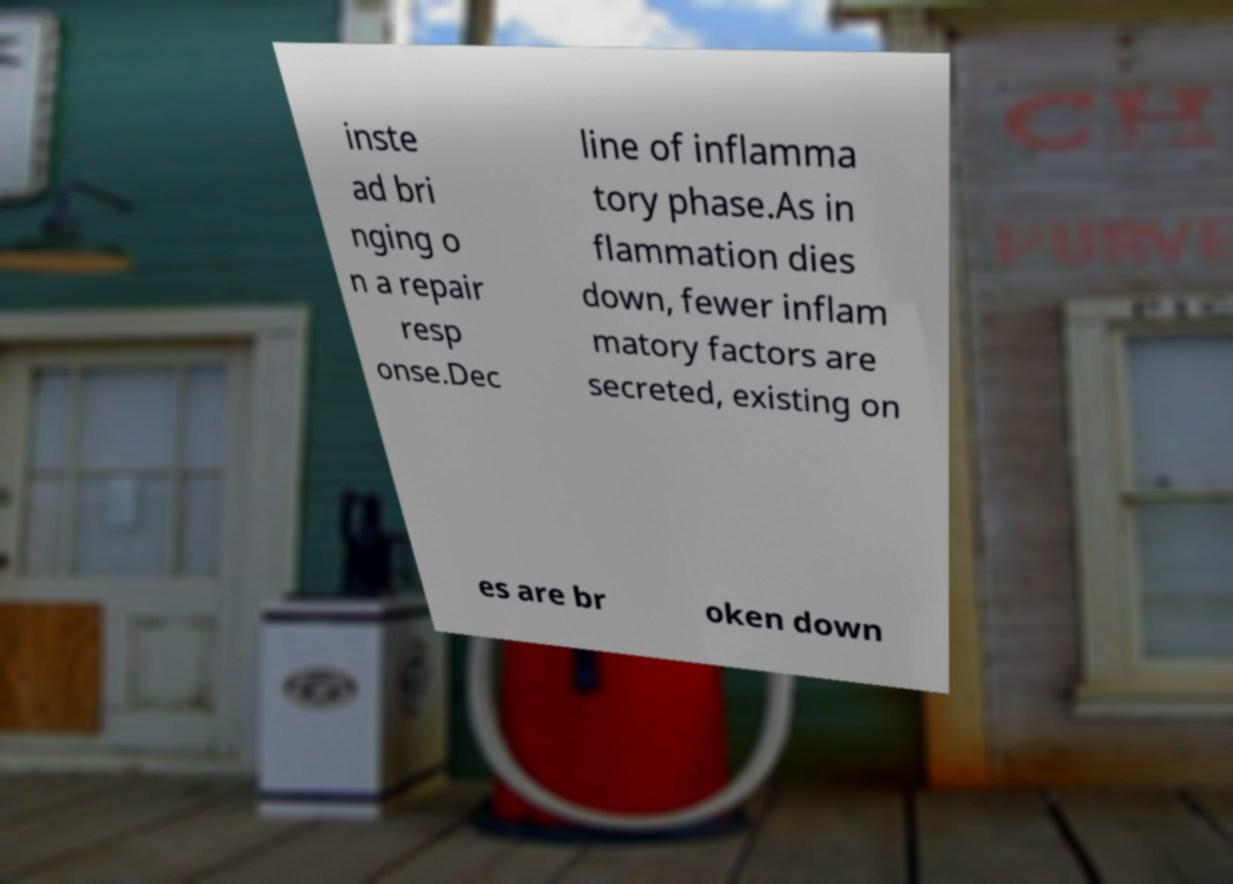Could you extract and type out the text from this image? inste ad bri nging o n a repair resp onse.Dec line of inflamma tory phase.As in flammation dies down, fewer inflam matory factors are secreted, existing on es are br oken down 